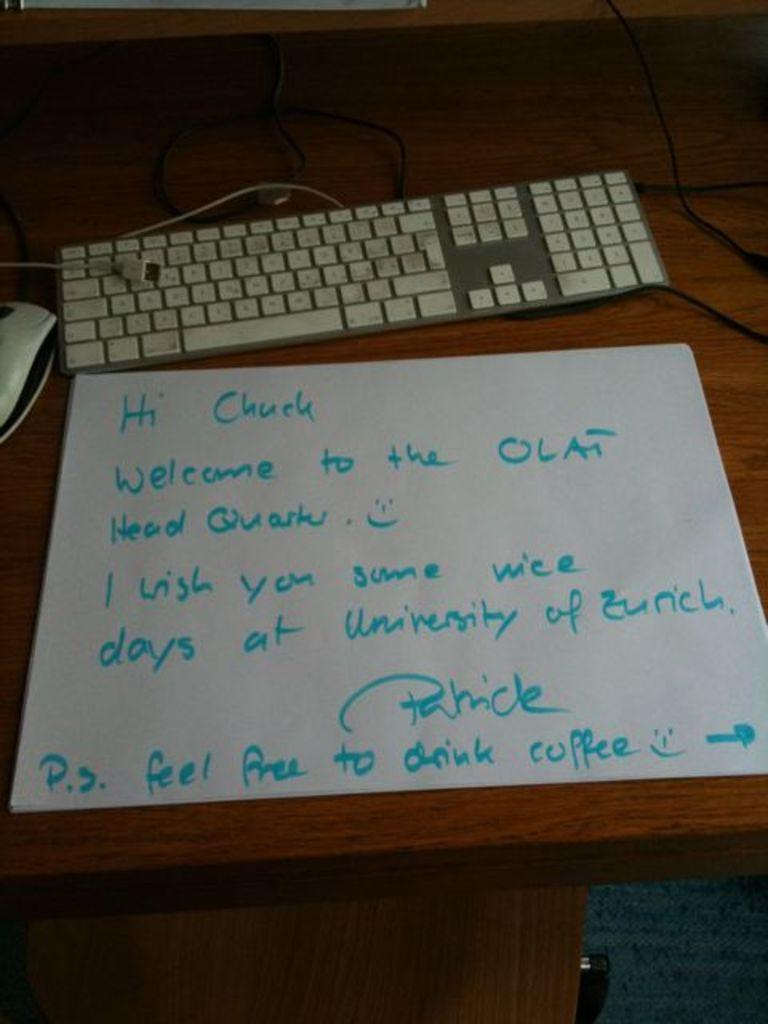Provide a one-sentence caption for the provided image. A note is sitting on a desk addressed to Chuck to welcome him to the university. 